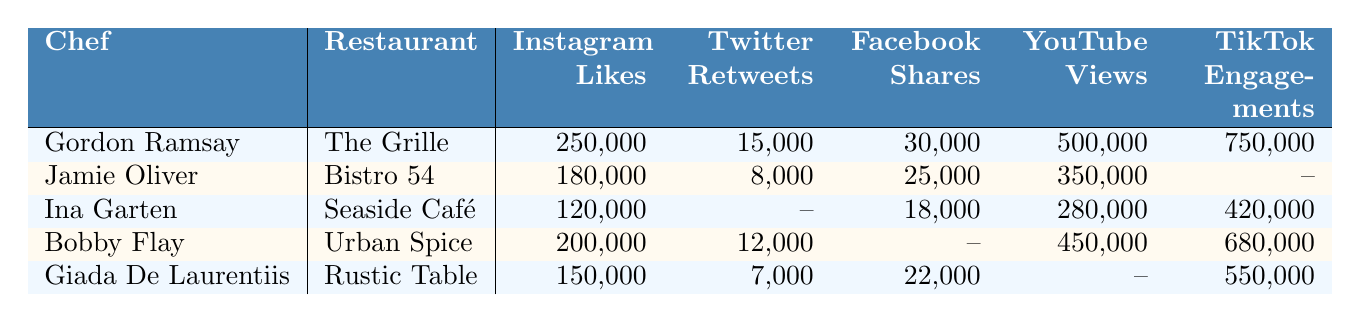What restaurant has the highest Instagram Likes? Looking at the Instagram Likes for each chef-restaurant combination, "The Grille" with Gordon Ramsay has the highest value of 250,000.
Answer: The Grille Which chef has the least Facebook Shares? Comparing the Facebook Shares across all chefs, Ina Garten has 18,000, which is the lowest value listed.
Answer: Ina Garten How many TikTok Engagements does Jamie Oliver have? The table shows that Jamie Oliver has no recorded TikTok Engagements, indicated by a dash.
Answer: None What is the total number of YouTube Views by Gordon Ramsay and Bobby Flay? Adding the YouTube Views from both chefs, Gordon Ramsay has 500,000 views and Bobby Flay has 450,000 views. The total is 500,000 + 450,000 = 950,000.
Answer: 950,000 Did Giada De Laurentiis receive more Twitter Retweets than Ina Garten? Giada had 7,000 Twitter Retweets while Ina Garten has no recorded Retweets (indicated by a dash). Since 7,000 is greater than 0, Giada has more.
Answer: Yes What is the average number of Instagram Likes among all chefs? The Instagram Likes for each chef are 250,000, 180,000, 120,000, 200,000, and 150,000. Adding them gives 1,000,000. Dividing by 5 chefs results in an average of 1,000,000 / 5 = 200,000.
Answer: 200,000 Which chef has the most YouTube Views? Analyzing the YouTube Views, Gordon Ramsay leads with 500,000 views compared to the others listed.
Answer: Gordon Ramsay Is there a chef with recorded metrics across all platforms? Checking the table, only Gordon Ramsay has metrics for all platforms listed; the rest have at least one missing value.
Answer: Yes How many more Instagram Likes does Bobby Flay have compared to Giada De Laurentiis? Bobby Flay has 200,000 Instagram Likes while Giada has 150,000. The difference is 200,000 - 150,000 = 50,000.
Answer: 50,000 Which chef has the highest TikTok Engagements and how many? Among the listed chefs, Bobby Flay has the highest with 680,000 TikTok Engagements.
Answer: Bobby Flay with 680,000 